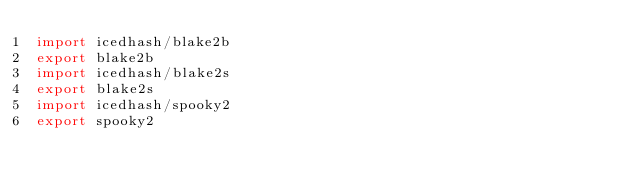Convert code to text. <code><loc_0><loc_0><loc_500><loc_500><_Nim_>import icedhash/blake2b
export blake2b
import icedhash/blake2s
export blake2s
import icedhash/spooky2
export spooky2

</code> 